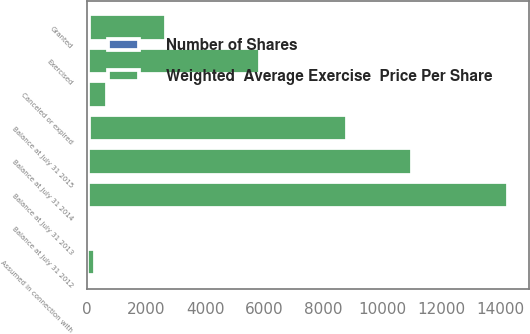Convert chart. <chart><loc_0><loc_0><loc_500><loc_500><stacked_bar_chart><ecel><fcel>Balance at July 31 2012<fcel>Granted<fcel>Exercised<fcel>Canceled or expired<fcel>Balance at July 31 2013<fcel>Assumed in connection with<fcel>Balance at July 31 2014<fcel>Balance at July 31 2015<nl><fcel>Weighted  Average Exercise  Price Per Share<fcel>69.13<fcel>2607<fcel>5826<fcel>636<fcel>14206<fcel>261<fcel>10938<fcel>8713<nl><fcel>Number of Shares<fcel>37.49<fcel>62.93<fcel>32.79<fcel>44.6<fcel>43.77<fcel>5.16<fcel>52.67<fcel>69.13<nl></chart> 